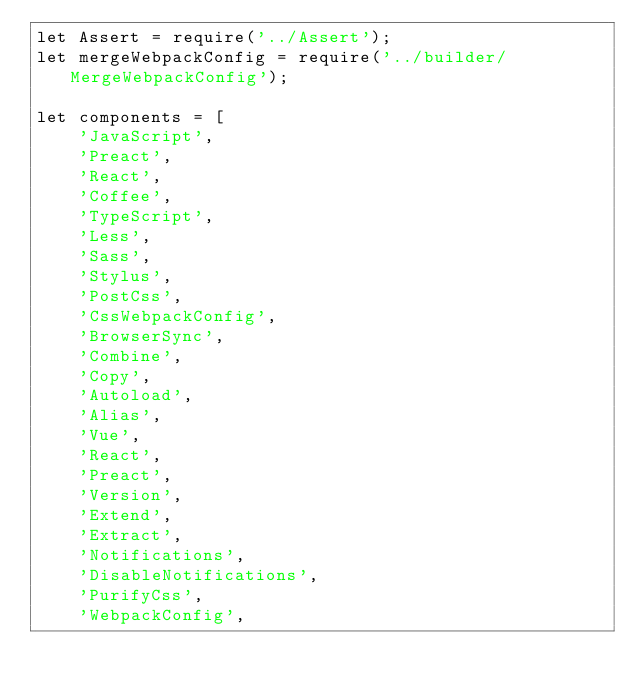<code> <loc_0><loc_0><loc_500><loc_500><_JavaScript_>let Assert = require('../Assert');
let mergeWebpackConfig = require('../builder/MergeWebpackConfig');

let components = [
    'JavaScript',
    'Preact',
    'React',
    'Coffee',
    'TypeScript',
    'Less',
    'Sass',
    'Stylus',
    'PostCss',
    'CssWebpackConfig',
    'BrowserSync',
    'Combine',
    'Copy',
    'Autoload',
    'Alias',
    'Vue',
    'React',
    'Preact',
    'Version',
    'Extend',
    'Extract',
    'Notifications',
    'DisableNotifications',
    'PurifyCss',
    'WebpackConfig',</code> 